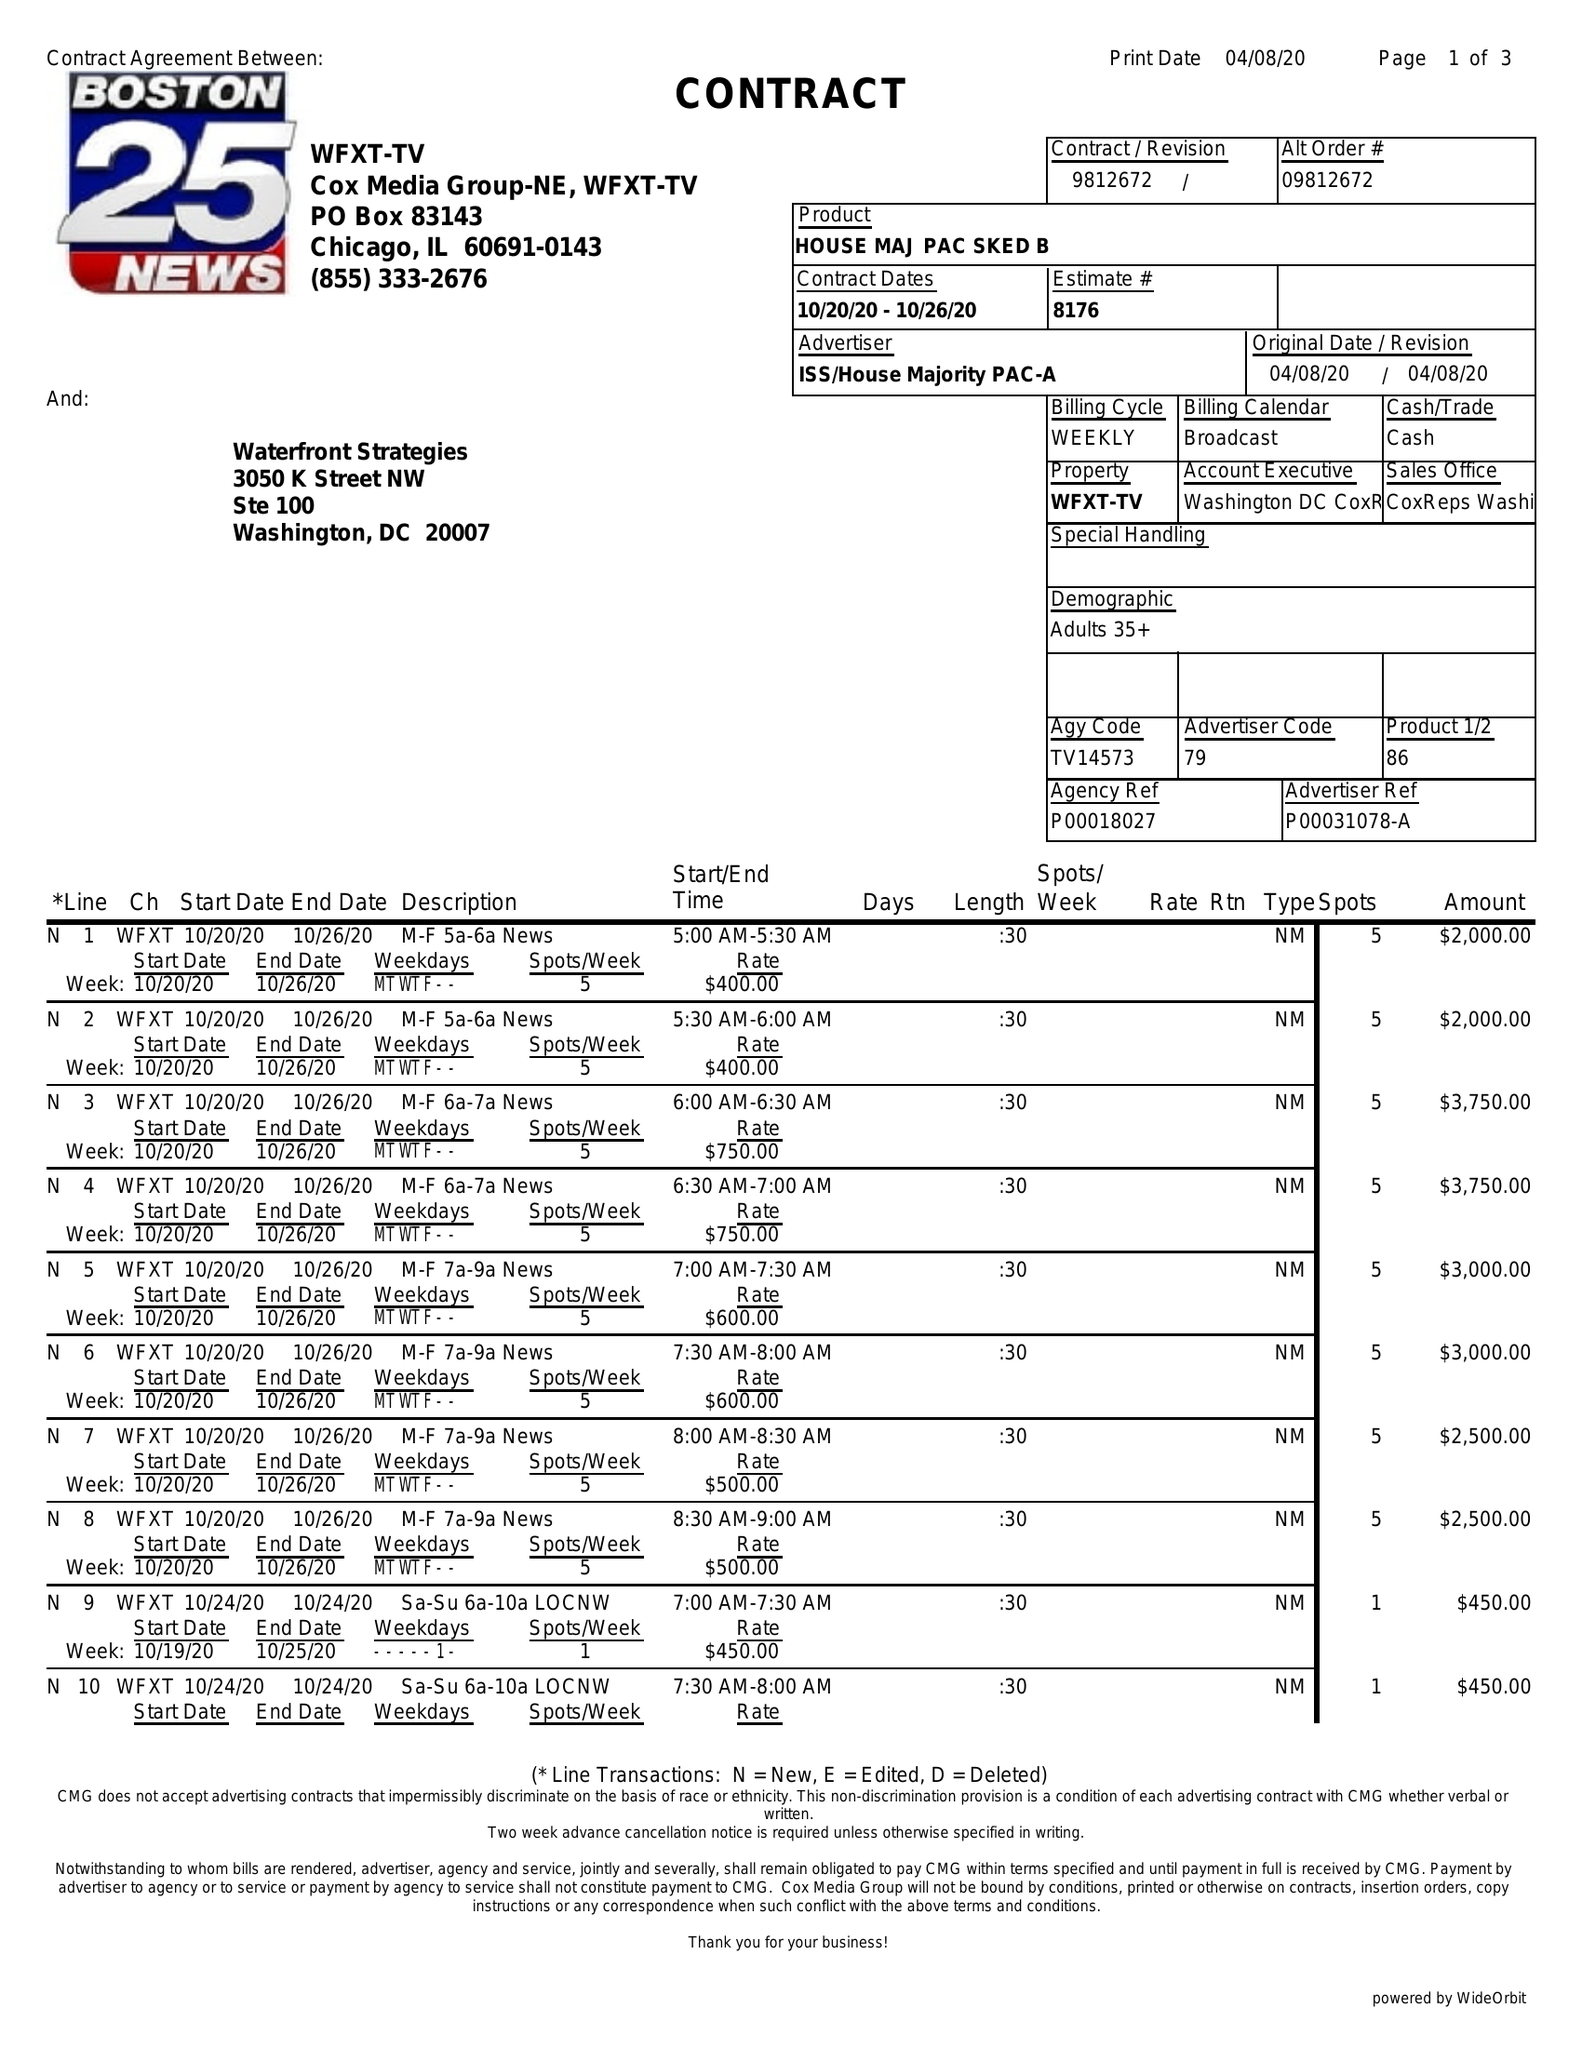What is the value for the gross_amount?
Answer the question using a single word or phrase. 97700.00 